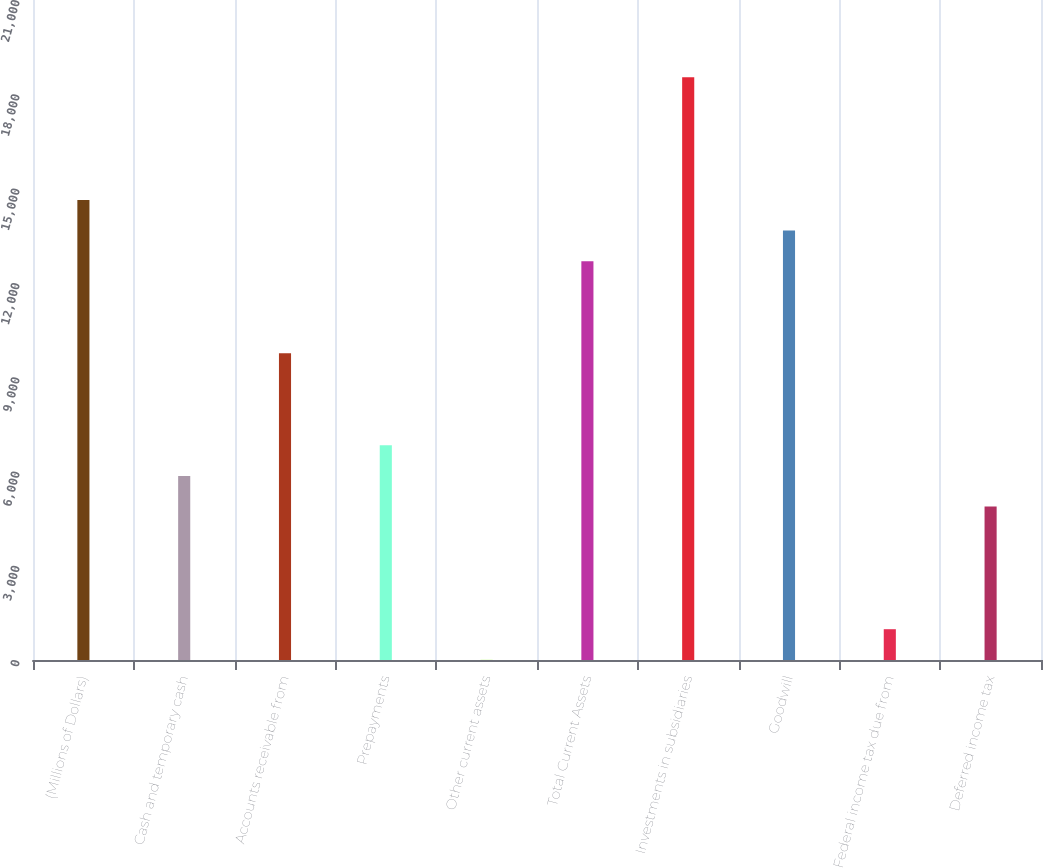Convert chart. <chart><loc_0><loc_0><loc_500><loc_500><bar_chart><fcel>(Millions of Dollars)<fcel>Cash and temporary cash<fcel>Accounts receivable from<fcel>Prepayments<fcel>Other current assets<fcel>Total Current Assets<fcel>Investments in subsidiaries<fcel>Goodwill<fcel>Federal income tax due from<fcel>Deferred income tax<nl><fcel>14639.5<fcel>5858.2<fcel>9761<fcel>6833.9<fcel>4<fcel>12688.1<fcel>18542.3<fcel>13663.8<fcel>979.7<fcel>4882.5<nl></chart> 